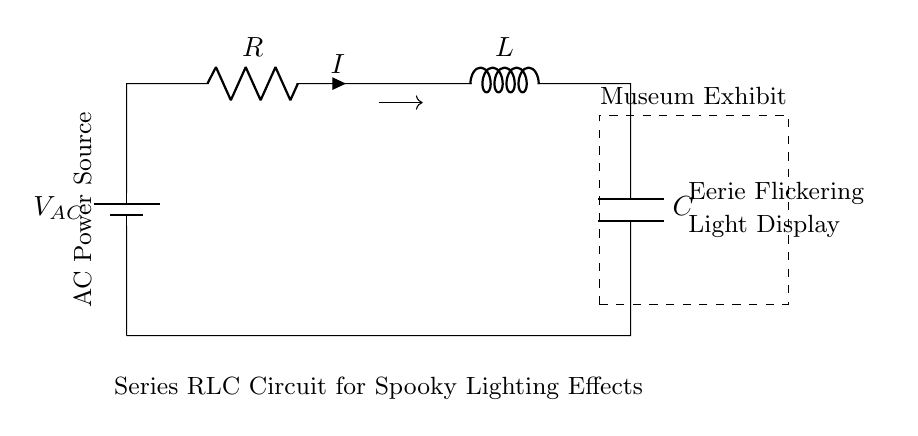What type of circuit is this? This is a series RLC circuit, indicated by the presence of a resistor, inductor, and capacitor connected in a single path.
Answer: series RLC circuit What does the AC power source provide? The AC power source provides alternating current to the circuit, which is necessary for creating the flickering light effects indicated in the exhibit description.
Answer: alternating current What component is responsible for the flickering effect? The flickering effect is primarily due to the interactions between the resistor, inductor, and capacitor, particularly how they store and release energy.
Answer: resistor, inductor, and capacitor What is the role of the capacitor in the circuit? The capacitor temporarily stores electrical energy and helps control the timing of the flickering effects by releasing energy at intervals.
Answer: store electrical energy How does the inductor affect current flow? The inductor resists changes in current flow due to its property of inductance, which can help smooth out rapid changes, contributing to the circuit's overall flickering behavior.
Answer: resists changes in current flow What happens when the resistance is increased? Increasing the resistance generally leads to a decrease in current, which could result in a less pronounced flickering effect in the lighting display.
Answer: less pronounced flickering What is the function of the resistor in this circuit? The resistor limits the current flowing through the circuit, helping to control the brightness and stability of the lighting effects created by the combination of RLC components.
Answer: limit current flow 